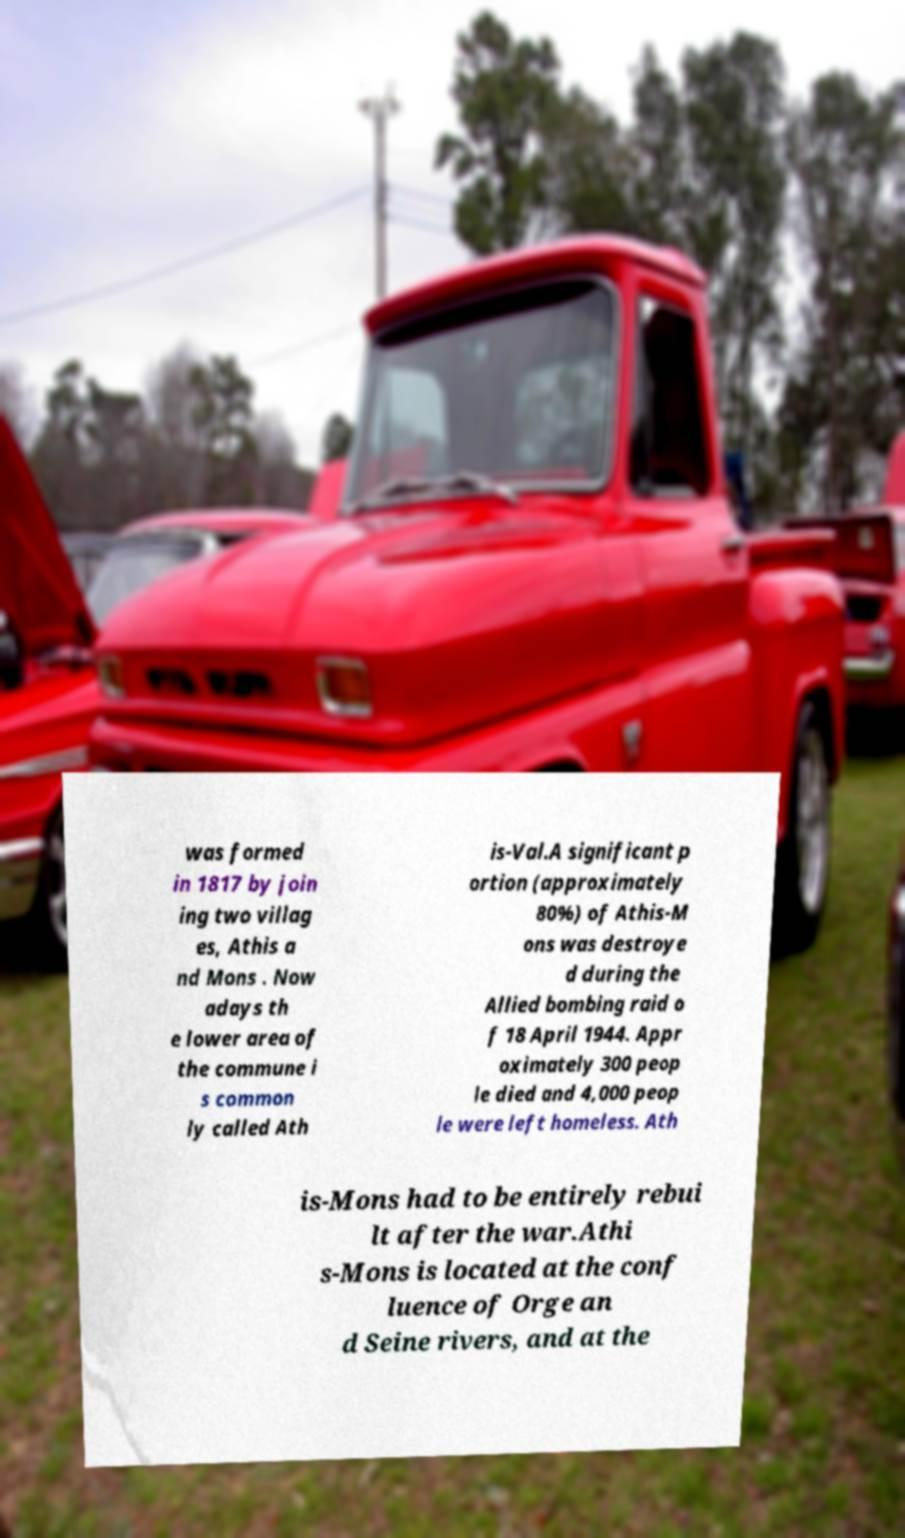Could you extract and type out the text from this image? was formed in 1817 by join ing two villag es, Athis a nd Mons . Now adays th e lower area of the commune i s common ly called Ath is-Val.A significant p ortion (approximately 80%) of Athis-M ons was destroye d during the Allied bombing raid o f 18 April 1944. Appr oximately 300 peop le died and 4,000 peop le were left homeless. Ath is-Mons had to be entirely rebui lt after the war.Athi s-Mons is located at the conf luence of Orge an d Seine rivers, and at the 